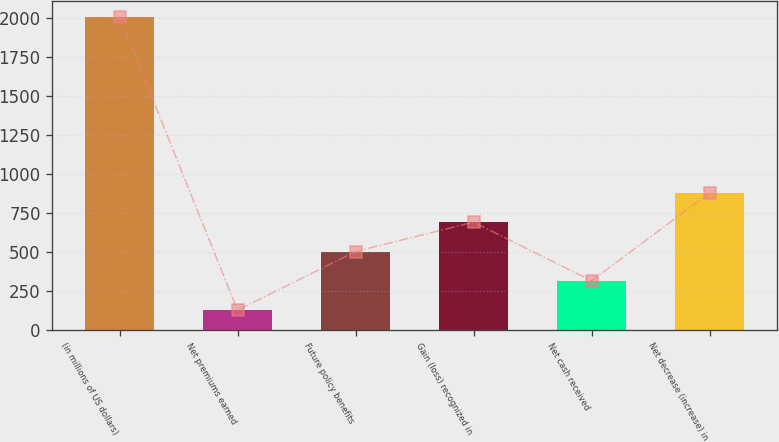Convert chart to OTSL. <chart><loc_0><loc_0><loc_500><loc_500><bar_chart><fcel>(in millions of US dollars)<fcel>Net premiums earned<fcel>Future policy benefits<fcel>Gain (loss) recognized in<fcel>Net cash received<fcel>Net decrease (increase) in<nl><fcel>2008<fcel>124<fcel>500.8<fcel>689.2<fcel>312.4<fcel>877.6<nl></chart> 